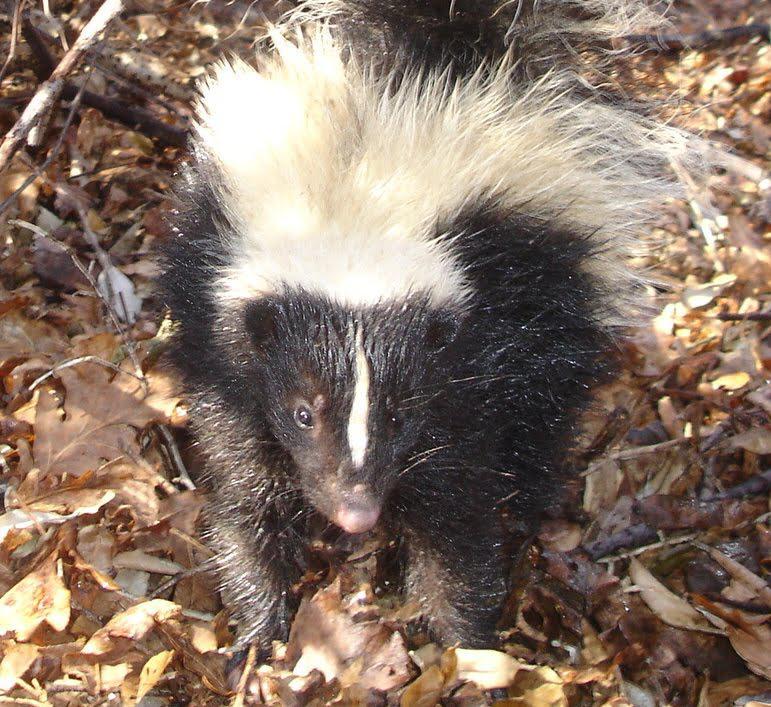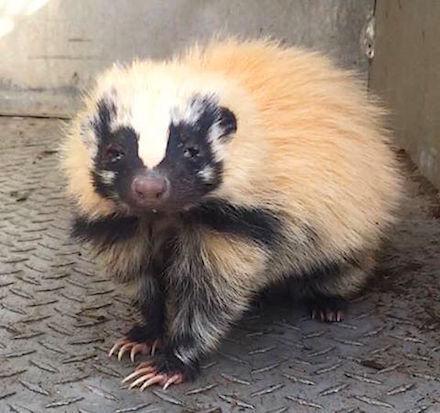The first image is the image on the left, the second image is the image on the right. Evaluate the accuracy of this statement regarding the images: "There are exactly two skunks.". Is it true? Answer yes or no. Yes. The first image is the image on the left, the second image is the image on the right. Analyze the images presented: Is the assertion "There is one skunk in one image, and more than one skunk in the other image." valid? Answer yes or no. No. 